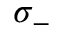<formula> <loc_0><loc_0><loc_500><loc_500>\sigma _ { - }</formula> 